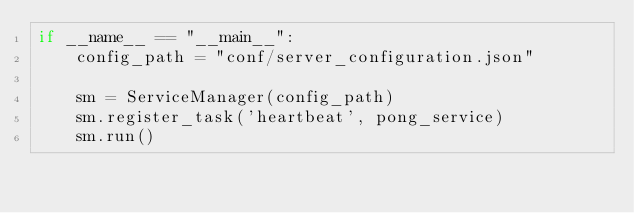<code> <loc_0><loc_0><loc_500><loc_500><_Python_>if __name__ == "__main__":
    config_path = "conf/server_configuration.json"

    sm = ServiceManager(config_path)
    sm.register_task('heartbeat', pong_service)
    sm.run()</code> 